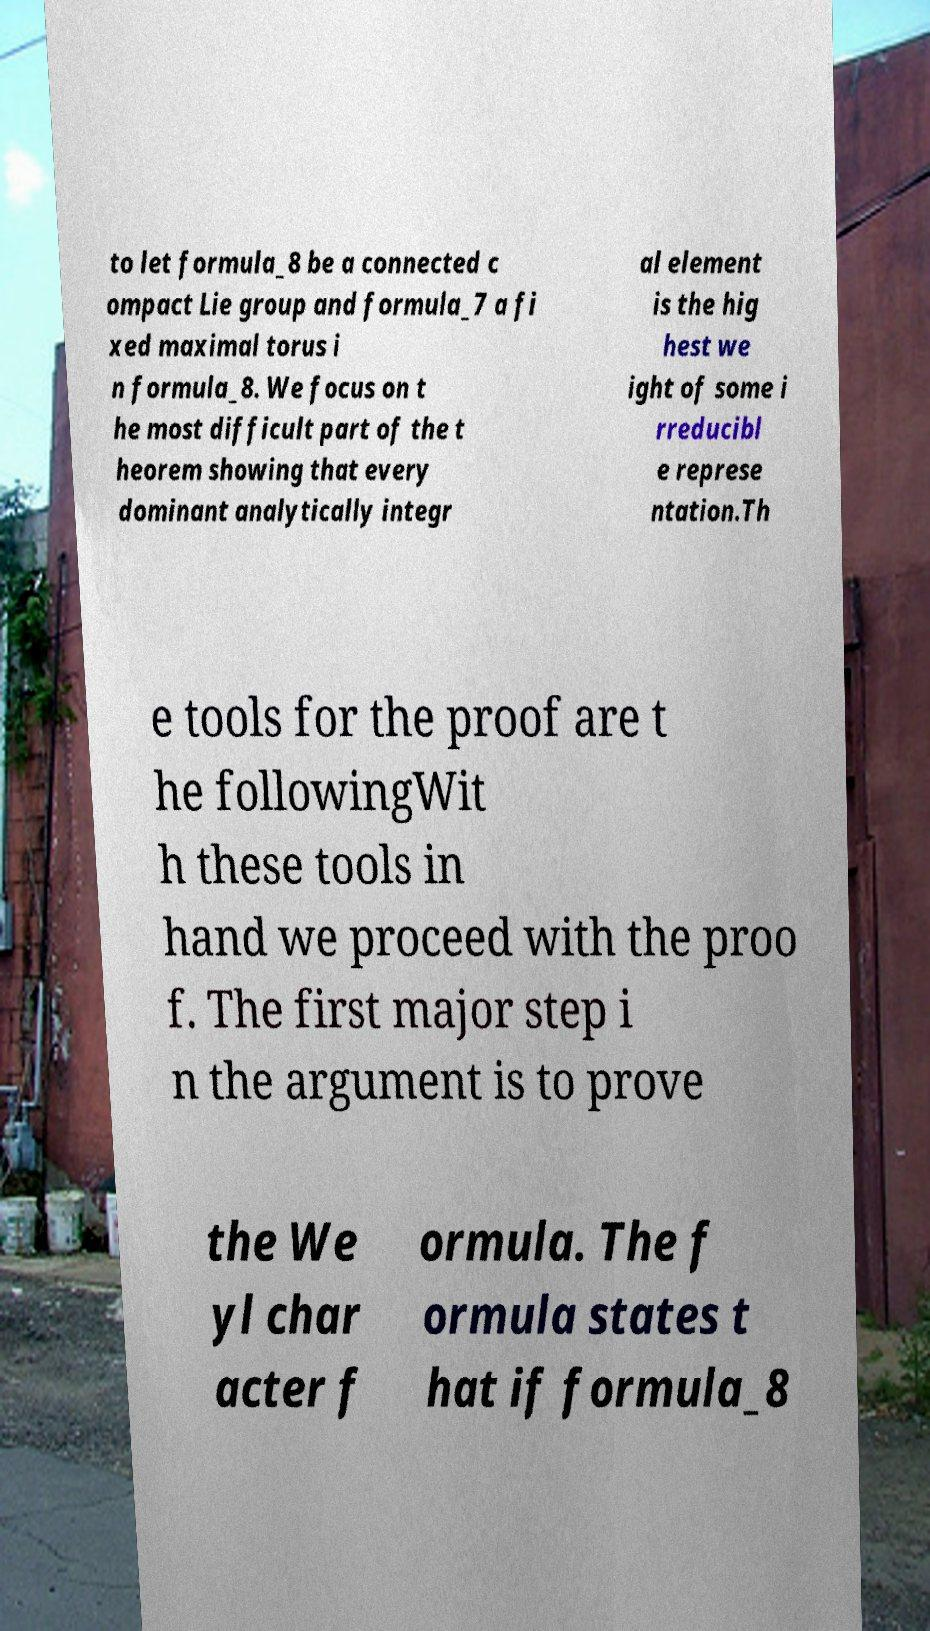Please read and relay the text visible in this image. What does it say? to let formula_8 be a connected c ompact Lie group and formula_7 a fi xed maximal torus i n formula_8. We focus on t he most difficult part of the t heorem showing that every dominant analytically integr al element is the hig hest we ight of some i rreducibl e represe ntation.Th e tools for the proof are t he followingWit h these tools in hand we proceed with the proo f. The first major step i n the argument is to prove the We yl char acter f ormula. The f ormula states t hat if formula_8 